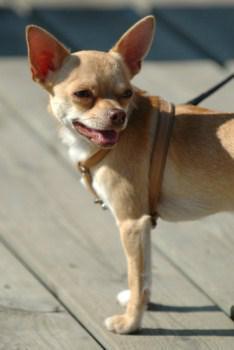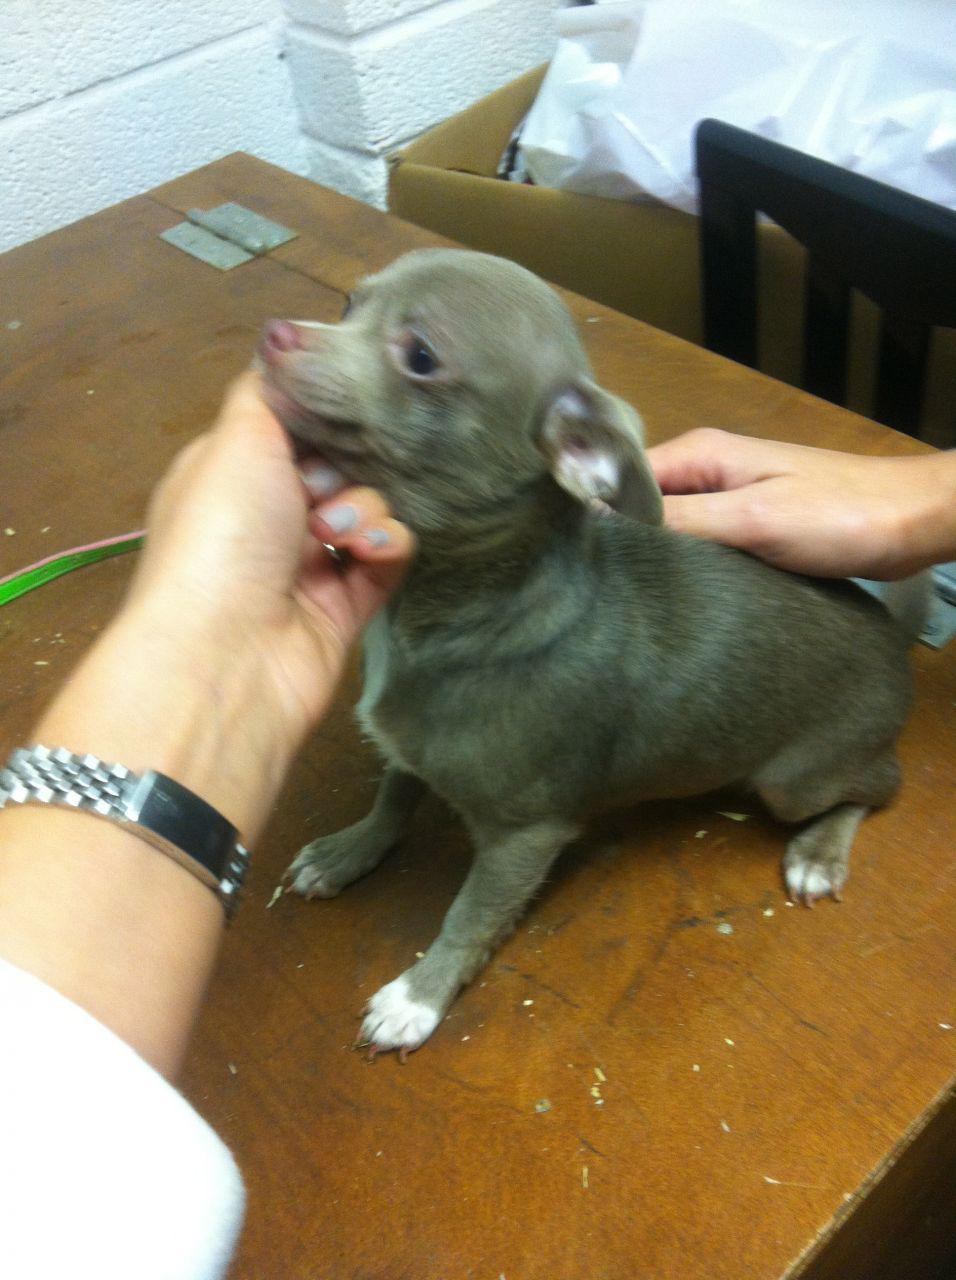The first image is the image on the left, the second image is the image on the right. For the images displayed, is the sentence "A cup with a handle is pictured with a tiny dog, in one image." factually correct? Answer yes or no. No. The first image is the image on the left, the second image is the image on the right. For the images displayed, is the sentence "A cup is pictured with a chihuahua." factually correct? Answer yes or no. No. 